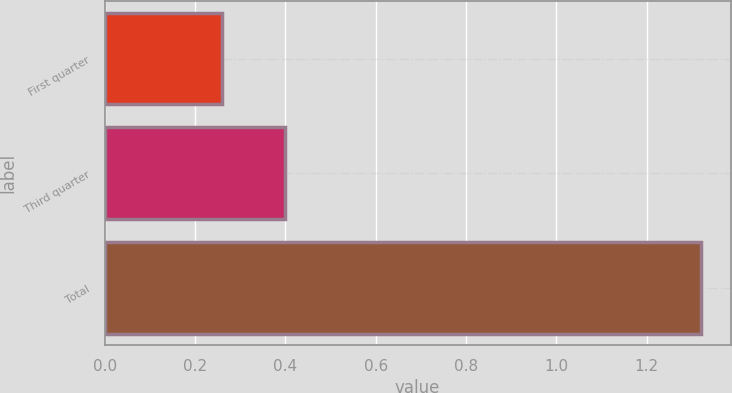<chart> <loc_0><loc_0><loc_500><loc_500><bar_chart><fcel>First quarter<fcel>Third quarter<fcel>Total<nl><fcel>0.26<fcel>0.4<fcel>1.32<nl></chart> 